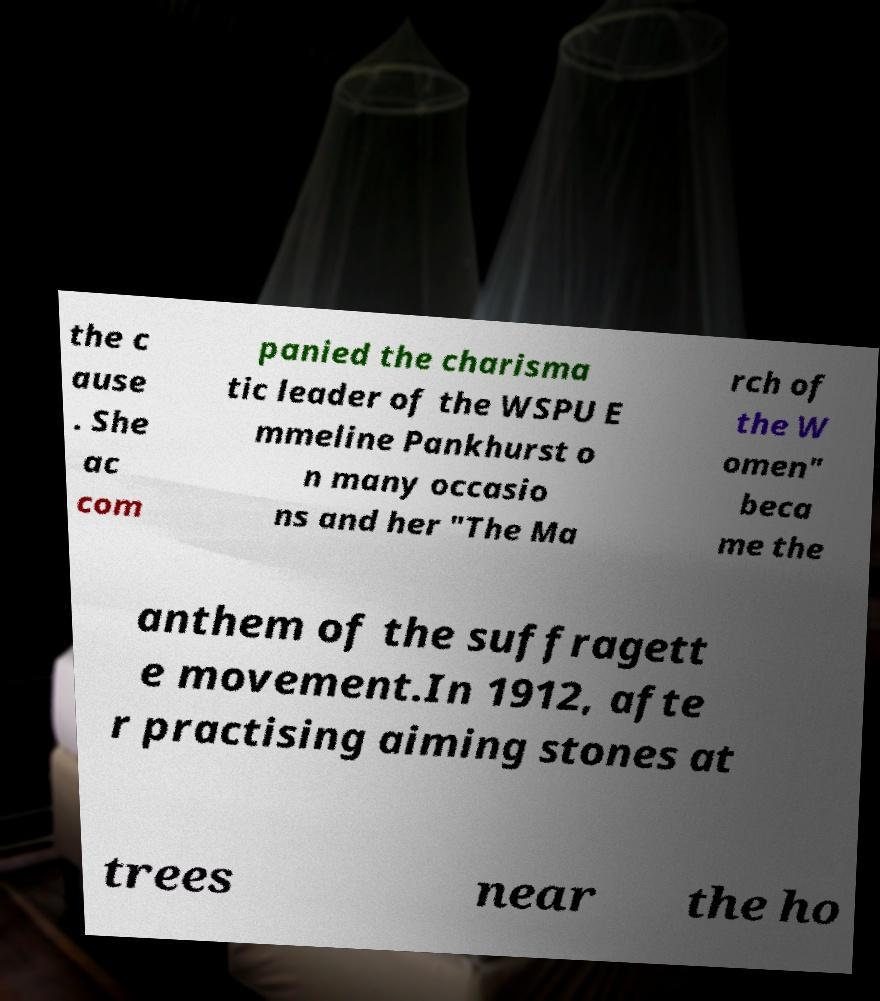Please identify and transcribe the text found in this image. the c ause . She ac com panied the charisma tic leader of the WSPU E mmeline Pankhurst o n many occasio ns and her "The Ma rch of the W omen" beca me the anthem of the suffragett e movement.In 1912, afte r practising aiming stones at trees near the ho 